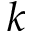<formula> <loc_0><loc_0><loc_500><loc_500>k</formula> 